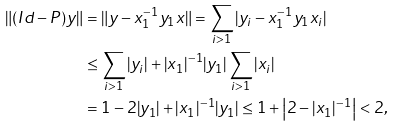<formula> <loc_0><loc_0><loc_500><loc_500>\| ( I d - P ) y \| & = \| y - x _ { 1 } ^ { - 1 } y _ { 1 } x \| = \sum _ { i > 1 } | y _ { i } - x _ { 1 } ^ { - 1 } y _ { 1 } x _ { i } | \\ & \leq \sum _ { i > 1 } | y _ { i } | + | x _ { 1 } | ^ { - 1 } | y _ { 1 } | \sum _ { i > 1 } | x _ { i } | \\ & = 1 - 2 | y _ { 1 } | + | x _ { 1 } | ^ { - 1 } | y _ { 1 } | \leq 1 + \left | 2 - | x _ { 1 } | ^ { - 1 } \right | < 2 ,</formula> 